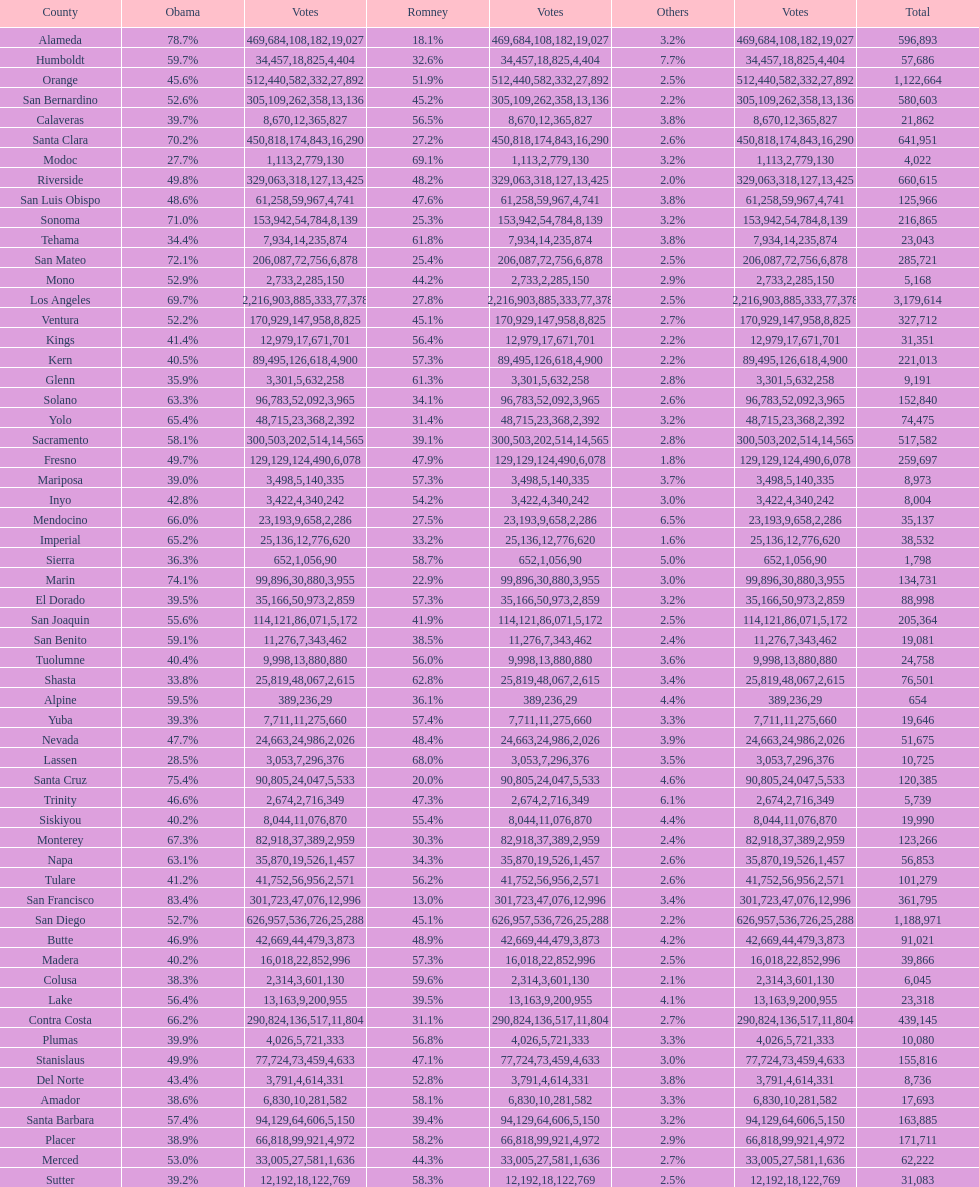What is the total number of votes for amador? 17693. 